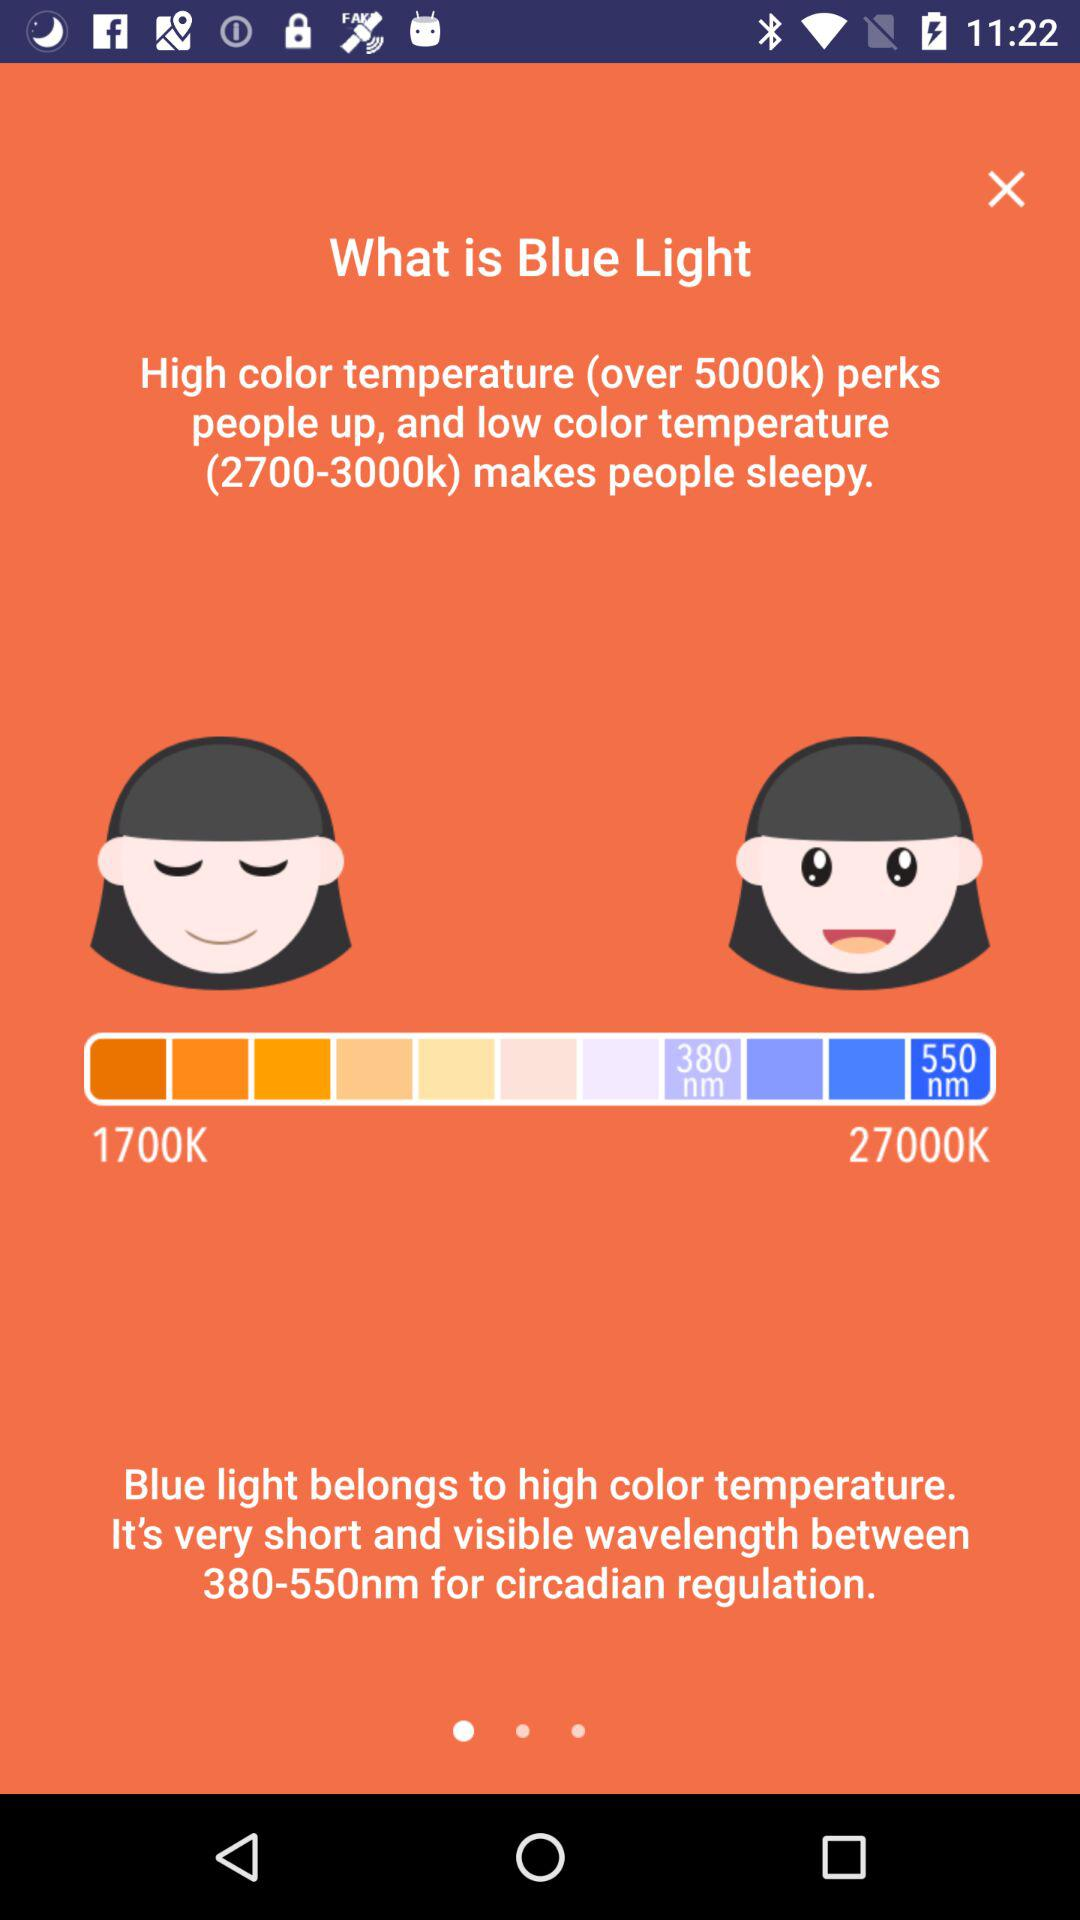Which color perks people up? The color that perks people up is one with a high color temperature (over 5000k). 